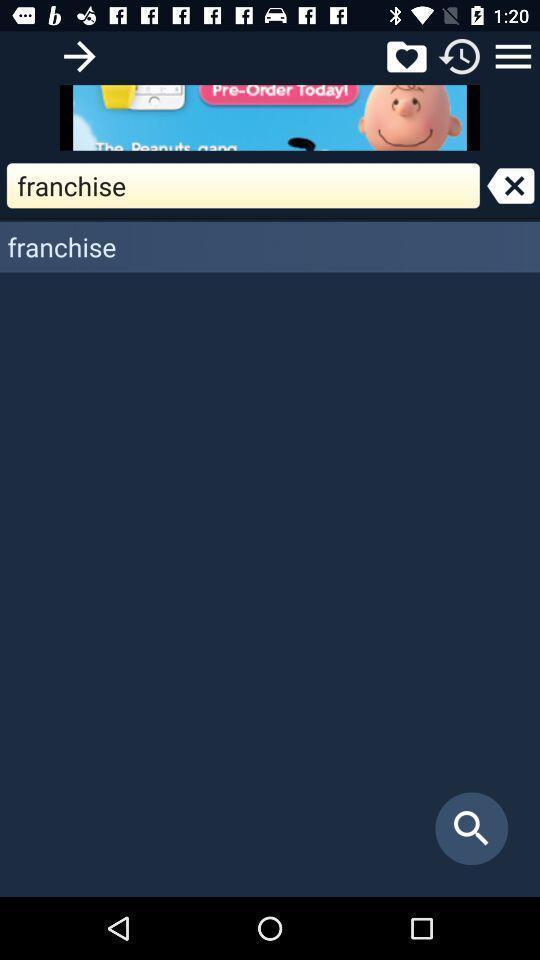Please provide a description for this image. Search page and other options displayed of an dictionary application. 